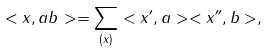<formula> <loc_0><loc_0><loc_500><loc_500>< x , a b > = \sum _ { ( x ) } < x ^ { \prime } , a > < x ^ { \prime \prime } , b > ,</formula> 